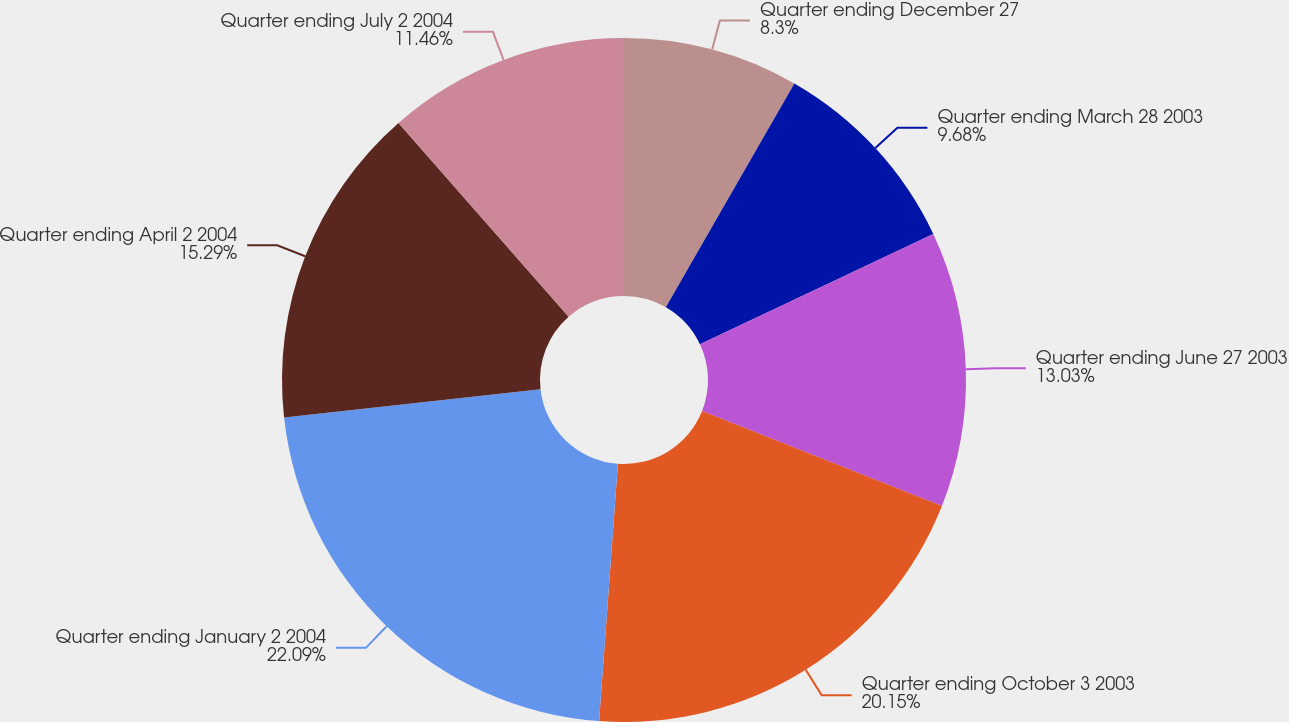Convert chart to OTSL. <chart><loc_0><loc_0><loc_500><loc_500><pie_chart><fcel>Quarter ending December 27<fcel>Quarter ending March 28 2003<fcel>Quarter ending June 27 2003<fcel>Quarter ending October 3 2003<fcel>Quarter ending January 2 2004<fcel>Quarter ending April 2 2004<fcel>Quarter ending July 2 2004<nl><fcel>8.3%<fcel>9.68%<fcel>13.03%<fcel>20.15%<fcel>22.09%<fcel>15.29%<fcel>11.46%<nl></chart> 